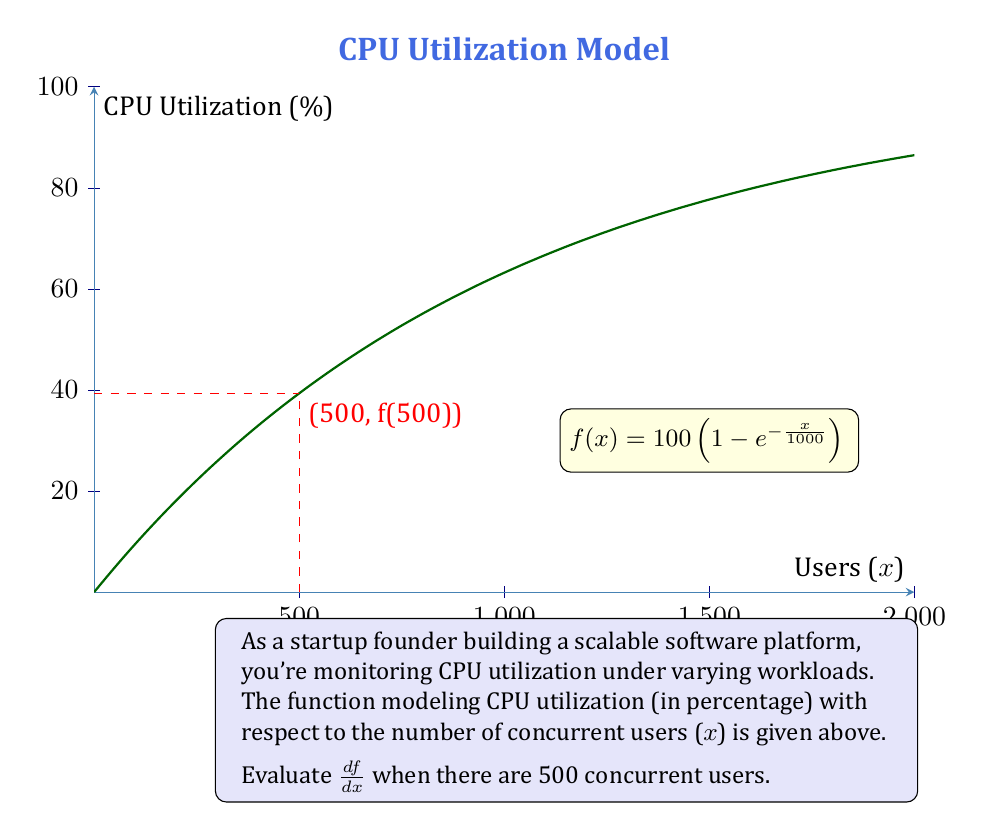Can you solve this math problem? Let's approach this step-by-step:

1) We start with the function:
   $$f(x) = 100 \left(1 - e^{-\frac{x}{1000}}\right)$$

2) To find $\frac{df}{dx}$, we need to apply the chain rule:
   $$\frac{df}{dx} = 100 \cdot \frac{d}{dx}\left(-e^{-\frac{x}{1000}}\right)$$

3) Using the chain rule again:
   $$\frac{df}{dx} = 100 \cdot \left(-e^{-\frac{x}{1000}}\right) \cdot \frac{d}{dx}\left(-\frac{x}{1000}\right)$$

4) Simplify:
   $$\frac{df}{dx} = 100 \cdot e^{-\frac{x}{1000}} \cdot \frac{1}{1000}$$

5) This can be written as:
   $$\frac{df}{dx} = \frac{1}{10}e^{-\frac{x}{1000}}$$

6) Now, we need to evaluate this at x = 500:
   $$\left.\frac{df}{dx}\right|_{x=500} = \frac{1}{10}e^{-\frac{500}{1000}}$$

7) Simplify:
   $$\left.\frac{df}{dx}\right|_{x=500} = \frac{1}{10}e^{-0.5} \approx 0.0606$$

This result indicates that when there are 500 concurrent users, the CPU utilization is increasing at a rate of about 6.06% per 100 users.
Answer: $\frac{1}{10}e^{-0.5} \approx 0.0606$ 